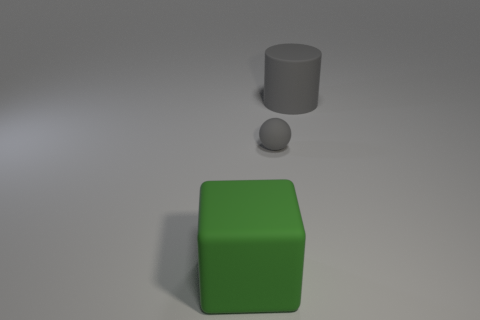Add 2 large gray cylinders. How many objects exist? 5 Subtract all spheres. How many objects are left? 2 Add 2 green rubber cubes. How many green rubber cubes are left? 3 Add 3 big gray cylinders. How many big gray cylinders exist? 4 Subtract 0 green balls. How many objects are left? 3 Subtract all gray cylinders. Subtract all brown balls. How many objects are left? 2 